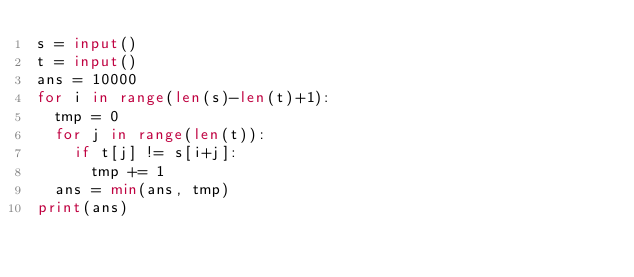<code> <loc_0><loc_0><loc_500><loc_500><_Python_>s = input()
t = input()
ans = 10000
for i in range(len(s)-len(t)+1):
	tmp = 0
	for j in range(len(t)):
		if t[j] != s[i+j]:
			tmp += 1
	ans = min(ans, tmp)
print(ans)</code> 